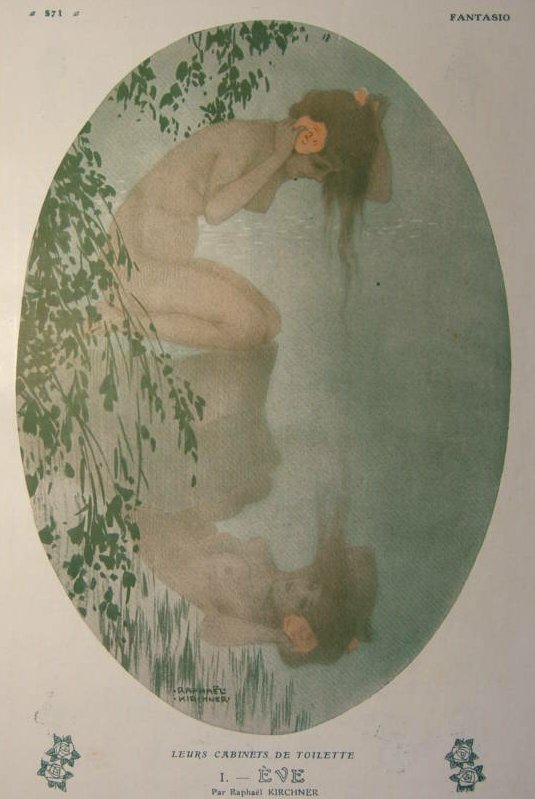What do you think the artist was trying to convey through this artwork? The artist likely aimed to convey a sense of tranquility, introspection, and the delicate connection between human and nature through this artwork. The serene pose of the woman, her reflection on the water, and the soft, harmonious colors all evoke a feeling of peace and unity with the natural surroundings. The image invites the viewer to pause and contemplate, perhaps reflecting on their own relationship with the natural world and the moments of quiet beauty that can be found within it. 